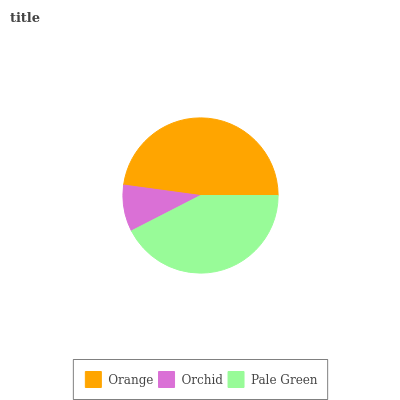Is Orchid the minimum?
Answer yes or no. Yes. Is Orange the maximum?
Answer yes or no. Yes. Is Pale Green the minimum?
Answer yes or no. No. Is Pale Green the maximum?
Answer yes or no. No. Is Pale Green greater than Orchid?
Answer yes or no. Yes. Is Orchid less than Pale Green?
Answer yes or no. Yes. Is Orchid greater than Pale Green?
Answer yes or no. No. Is Pale Green less than Orchid?
Answer yes or no. No. Is Pale Green the high median?
Answer yes or no. Yes. Is Pale Green the low median?
Answer yes or no. Yes. Is Orchid the high median?
Answer yes or no. No. Is Orchid the low median?
Answer yes or no. No. 